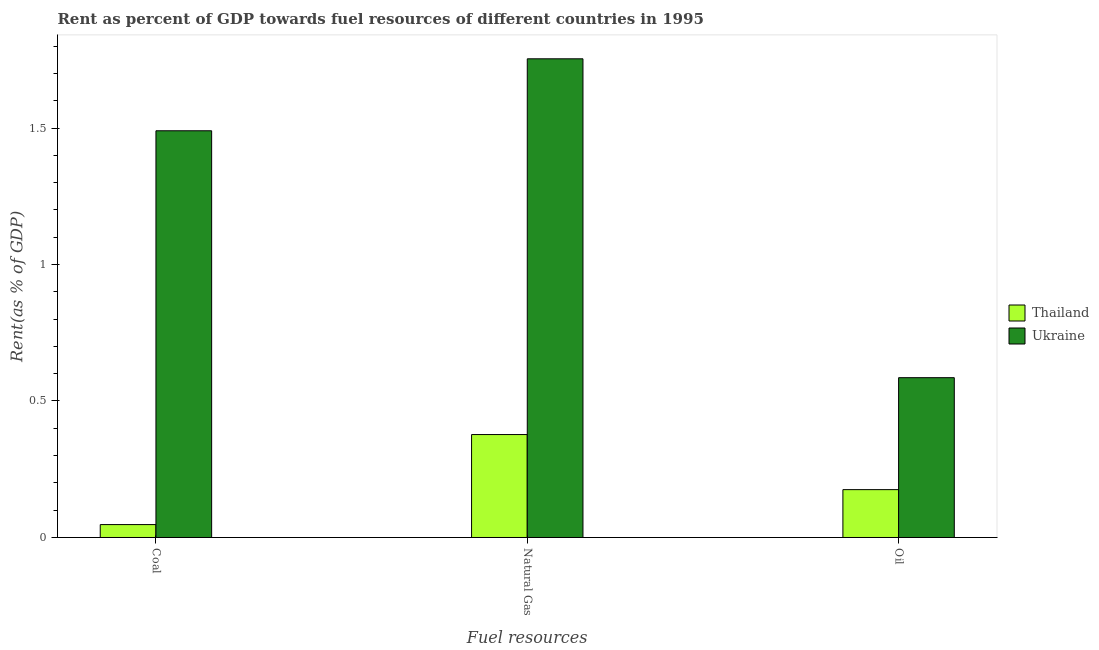How many groups of bars are there?
Offer a very short reply. 3. Are the number of bars per tick equal to the number of legend labels?
Keep it short and to the point. Yes. Are the number of bars on each tick of the X-axis equal?
Keep it short and to the point. Yes. What is the label of the 1st group of bars from the left?
Give a very brief answer. Coal. What is the rent towards oil in Thailand?
Offer a terse response. 0.18. Across all countries, what is the maximum rent towards coal?
Provide a short and direct response. 1.49. Across all countries, what is the minimum rent towards natural gas?
Give a very brief answer. 0.38. In which country was the rent towards oil maximum?
Offer a terse response. Ukraine. In which country was the rent towards oil minimum?
Give a very brief answer. Thailand. What is the total rent towards oil in the graph?
Your answer should be very brief. 0.76. What is the difference between the rent towards natural gas in Thailand and that in Ukraine?
Provide a short and direct response. -1.38. What is the difference between the rent towards oil in Ukraine and the rent towards natural gas in Thailand?
Your response must be concise. 0.21. What is the average rent towards natural gas per country?
Keep it short and to the point. 1.07. What is the difference between the rent towards oil and rent towards coal in Thailand?
Your answer should be compact. 0.13. In how many countries, is the rent towards natural gas greater than 0.5 %?
Offer a very short reply. 1. What is the ratio of the rent towards oil in Ukraine to that in Thailand?
Your answer should be compact. 3.34. Is the rent towards oil in Ukraine less than that in Thailand?
Your response must be concise. No. Is the difference between the rent towards coal in Ukraine and Thailand greater than the difference between the rent towards natural gas in Ukraine and Thailand?
Make the answer very short. Yes. What is the difference between the highest and the second highest rent towards oil?
Make the answer very short. 0.41. What is the difference between the highest and the lowest rent towards natural gas?
Keep it short and to the point. 1.38. What does the 1st bar from the left in Oil represents?
Provide a short and direct response. Thailand. What does the 2nd bar from the right in Coal represents?
Your answer should be very brief. Thailand. Are all the bars in the graph horizontal?
Keep it short and to the point. No. What is the difference between two consecutive major ticks on the Y-axis?
Ensure brevity in your answer.  0.5. Does the graph contain grids?
Ensure brevity in your answer.  No. How many legend labels are there?
Your answer should be compact. 2. What is the title of the graph?
Provide a short and direct response. Rent as percent of GDP towards fuel resources of different countries in 1995. What is the label or title of the X-axis?
Offer a very short reply. Fuel resources. What is the label or title of the Y-axis?
Your response must be concise. Rent(as % of GDP). What is the Rent(as % of GDP) of Thailand in Coal?
Provide a succinct answer. 0.05. What is the Rent(as % of GDP) of Ukraine in Coal?
Your answer should be compact. 1.49. What is the Rent(as % of GDP) of Thailand in Natural Gas?
Make the answer very short. 0.38. What is the Rent(as % of GDP) in Ukraine in Natural Gas?
Make the answer very short. 1.75. What is the Rent(as % of GDP) of Thailand in Oil?
Provide a succinct answer. 0.18. What is the Rent(as % of GDP) of Ukraine in Oil?
Your response must be concise. 0.59. Across all Fuel resources, what is the maximum Rent(as % of GDP) in Thailand?
Keep it short and to the point. 0.38. Across all Fuel resources, what is the maximum Rent(as % of GDP) in Ukraine?
Your response must be concise. 1.75. Across all Fuel resources, what is the minimum Rent(as % of GDP) in Thailand?
Your response must be concise. 0.05. Across all Fuel resources, what is the minimum Rent(as % of GDP) of Ukraine?
Your response must be concise. 0.59. What is the total Rent(as % of GDP) of Thailand in the graph?
Give a very brief answer. 0.6. What is the total Rent(as % of GDP) of Ukraine in the graph?
Make the answer very short. 3.83. What is the difference between the Rent(as % of GDP) of Thailand in Coal and that in Natural Gas?
Your answer should be very brief. -0.33. What is the difference between the Rent(as % of GDP) in Ukraine in Coal and that in Natural Gas?
Your answer should be compact. -0.26. What is the difference between the Rent(as % of GDP) in Thailand in Coal and that in Oil?
Provide a succinct answer. -0.13. What is the difference between the Rent(as % of GDP) in Ukraine in Coal and that in Oil?
Your answer should be compact. 0.9. What is the difference between the Rent(as % of GDP) in Thailand in Natural Gas and that in Oil?
Make the answer very short. 0.2. What is the difference between the Rent(as % of GDP) of Ukraine in Natural Gas and that in Oil?
Ensure brevity in your answer.  1.17. What is the difference between the Rent(as % of GDP) of Thailand in Coal and the Rent(as % of GDP) of Ukraine in Natural Gas?
Offer a terse response. -1.71. What is the difference between the Rent(as % of GDP) of Thailand in Coal and the Rent(as % of GDP) of Ukraine in Oil?
Provide a succinct answer. -0.54. What is the difference between the Rent(as % of GDP) in Thailand in Natural Gas and the Rent(as % of GDP) in Ukraine in Oil?
Your answer should be very brief. -0.21. What is the average Rent(as % of GDP) of Thailand per Fuel resources?
Give a very brief answer. 0.2. What is the average Rent(as % of GDP) of Ukraine per Fuel resources?
Offer a very short reply. 1.28. What is the difference between the Rent(as % of GDP) in Thailand and Rent(as % of GDP) in Ukraine in Coal?
Give a very brief answer. -1.44. What is the difference between the Rent(as % of GDP) of Thailand and Rent(as % of GDP) of Ukraine in Natural Gas?
Provide a short and direct response. -1.38. What is the difference between the Rent(as % of GDP) of Thailand and Rent(as % of GDP) of Ukraine in Oil?
Your response must be concise. -0.41. What is the ratio of the Rent(as % of GDP) of Thailand in Coal to that in Natural Gas?
Make the answer very short. 0.13. What is the ratio of the Rent(as % of GDP) in Ukraine in Coal to that in Natural Gas?
Offer a terse response. 0.85. What is the ratio of the Rent(as % of GDP) of Thailand in Coal to that in Oil?
Ensure brevity in your answer.  0.27. What is the ratio of the Rent(as % of GDP) in Ukraine in Coal to that in Oil?
Your response must be concise. 2.54. What is the ratio of the Rent(as % of GDP) of Thailand in Natural Gas to that in Oil?
Provide a succinct answer. 2.15. What is the ratio of the Rent(as % of GDP) in Ukraine in Natural Gas to that in Oil?
Keep it short and to the point. 3. What is the difference between the highest and the second highest Rent(as % of GDP) in Thailand?
Your answer should be compact. 0.2. What is the difference between the highest and the second highest Rent(as % of GDP) of Ukraine?
Ensure brevity in your answer.  0.26. What is the difference between the highest and the lowest Rent(as % of GDP) in Thailand?
Make the answer very short. 0.33. What is the difference between the highest and the lowest Rent(as % of GDP) of Ukraine?
Ensure brevity in your answer.  1.17. 